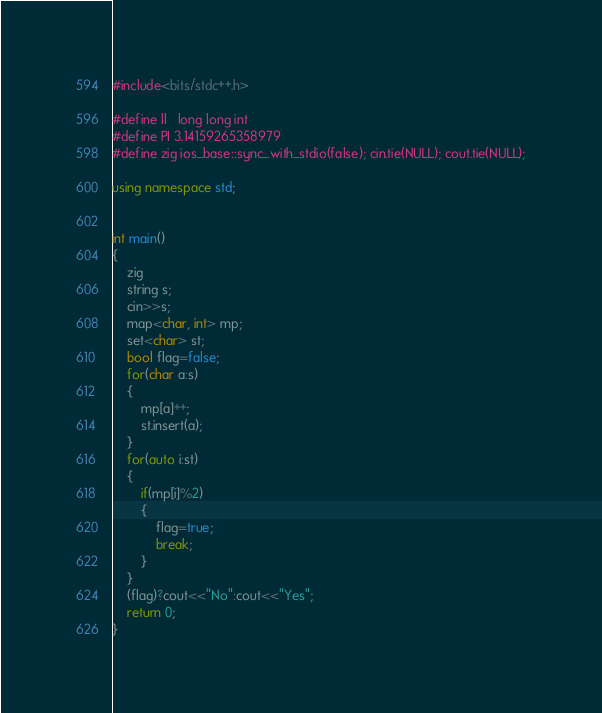Convert code to text. <code><loc_0><loc_0><loc_500><loc_500><_C++_>#include<bits/stdc++.h>

#define ll   long long int
#define PI 3.14159265358979
#define zig ios_base::sync_with_stdio(false); cin.tie(NULL); cout.tie(NULL);

using namespace std;


int main()
{
    zig
    string s;
    cin>>s;
    map<char, int> mp;
    set<char> st;
    bool flag=false;
    for(char a:s)
    {
        mp[a]++;
        st.insert(a);
    }
    for(auto i:st)
    {
        if(mp[i]%2)
        {
            flag=true;
            break;
        }
    }
    (flag)?cout<<"No":cout<<"Yes";
    return 0;
}
</code> 